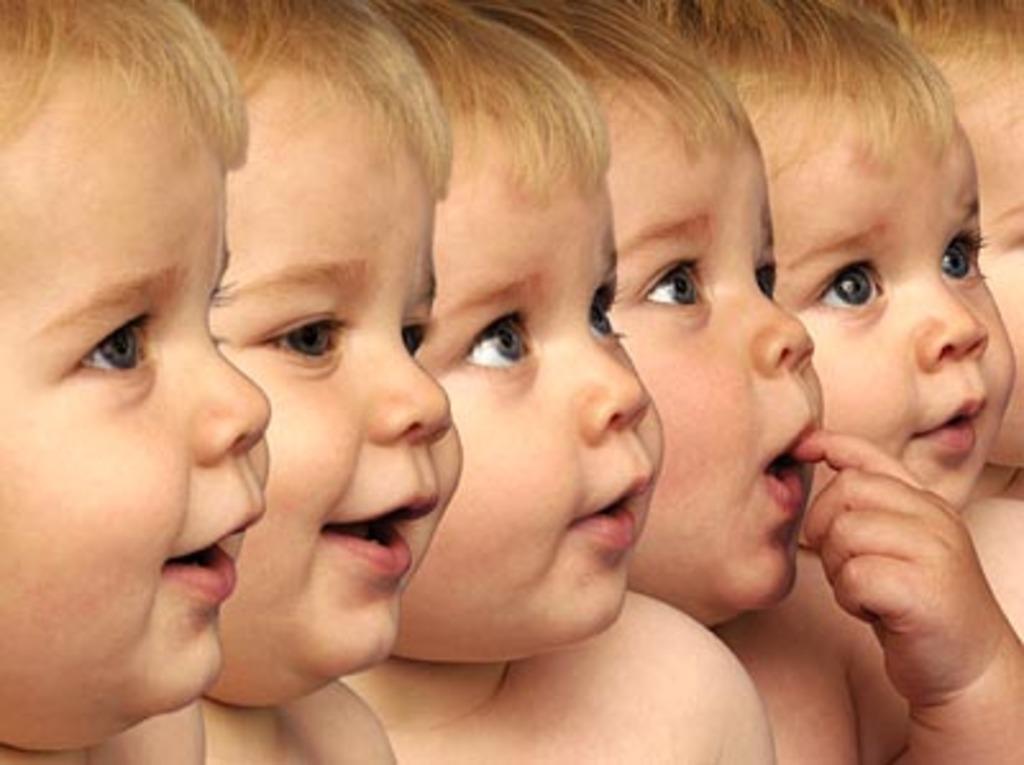How would you summarize this image in a sentence or two? This is an edited image. I can see a baby with different facial expressions. 